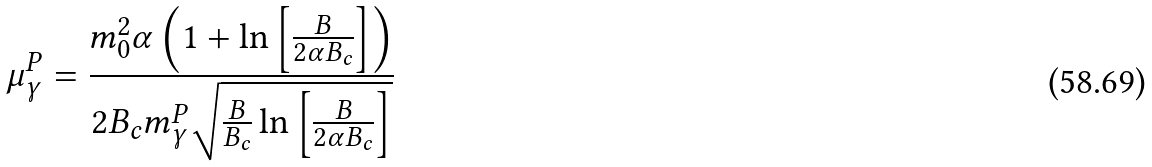Convert formula to latex. <formula><loc_0><loc_0><loc_500><loc_500>\mu _ { \gamma } ^ { P } = \frac { m _ { 0 } ^ { 2 } \alpha \left ( 1 + \ln \left [ \frac { B } { 2 \alpha B _ { c } } \right ] \right ) } { 2 B _ { c } m _ { \gamma } ^ { P } \sqrt { \frac { B } { B _ { c } } \ln \left [ \frac { B } { 2 \alpha B _ { c } } \right ] } }</formula> 